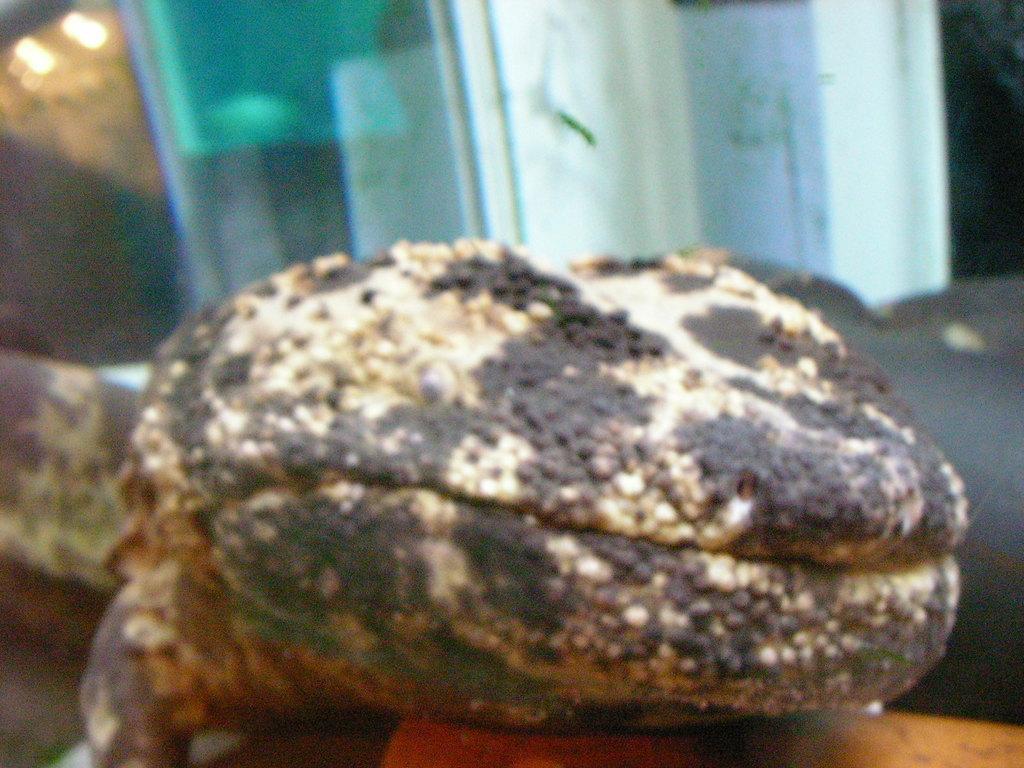Can you describe this image briefly? In this image there is an animal on the object. 